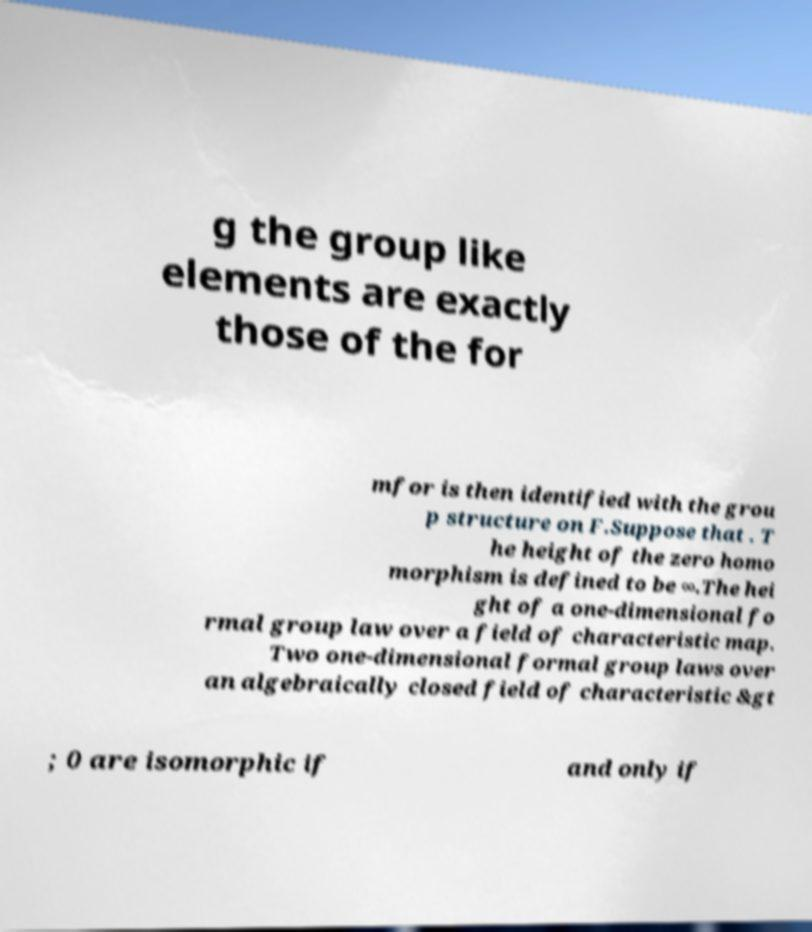I need the written content from this picture converted into text. Can you do that? g the group like elements are exactly those of the for mfor is then identified with the grou p structure on F.Suppose that . T he height of the zero homo morphism is defined to be ∞.The hei ght of a one-dimensional fo rmal group law over a field of characteristic map. Two one-dimensional formal group laws over an algebraically closed field of characteristic &gt ; 0 are isomorphic if and only if 